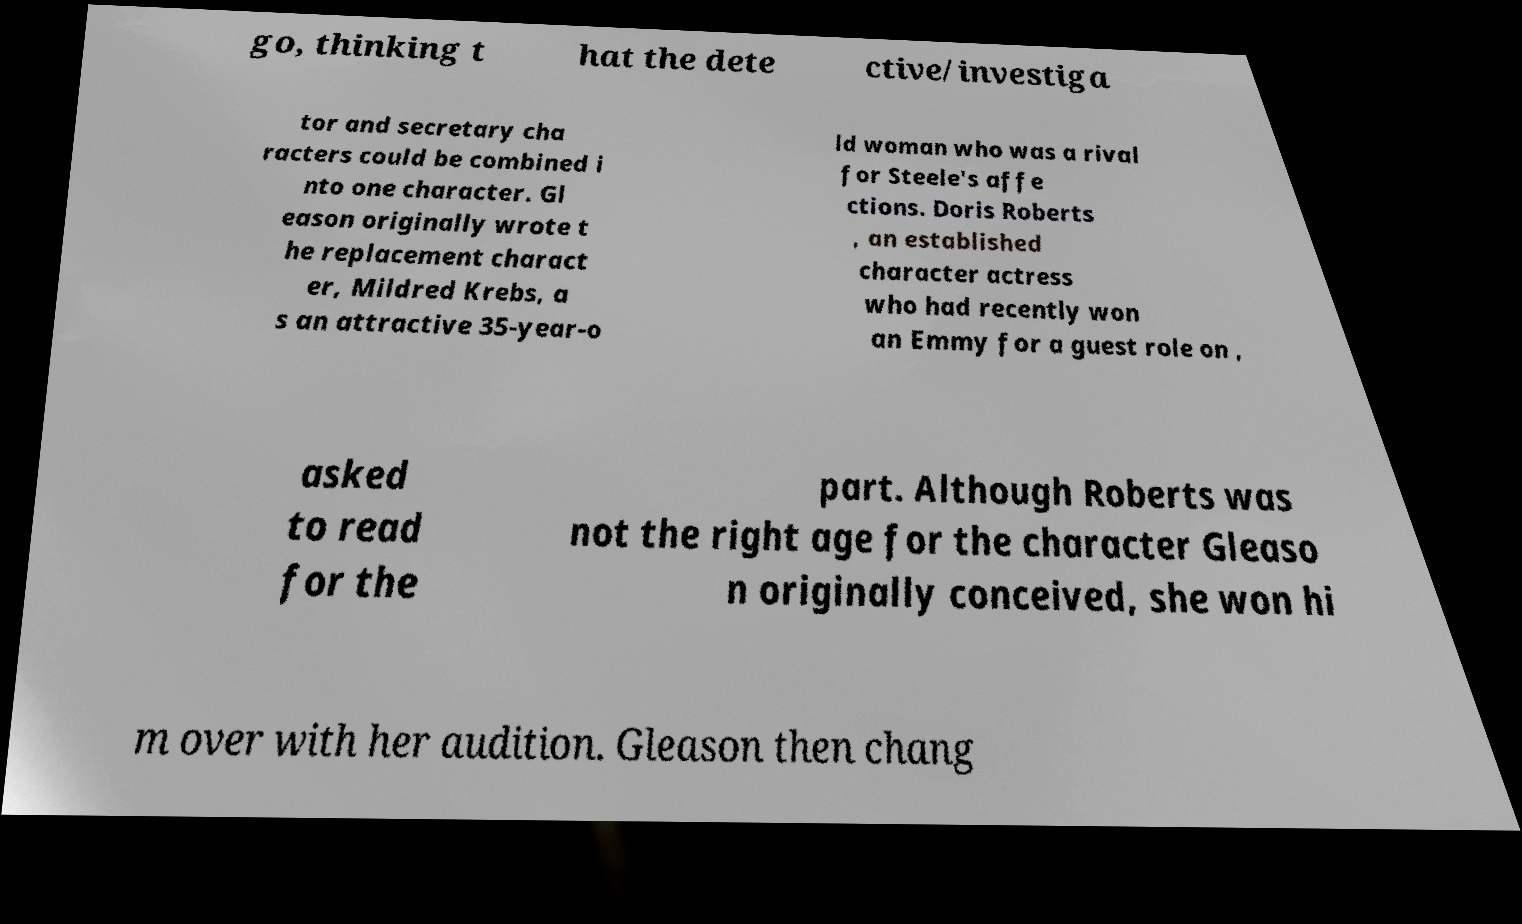Please read and relay the text visible in this image. What does it say? go, thinking t hat the dete ctive/investiga tor and secretary cha racters could be combined i nto one character. Gl eason originally wrote t he replacement charact er, Mildred Krebs, a s an attractive 35-year-o ld woman who was a rival for Steele's affe ctions. Doris Roberts , an established character actress who had recently won an Emmy for a guest role on , asked to read for the part. Although Roberts was not the right age for the character Gleaso n originally conceived, she won hi m over with her audition. Gleason then chang 